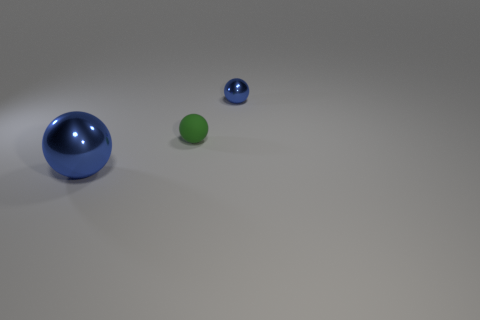What is the shape of the shiny thing that is the same color as the large metal sphere?
Provide a succinct answer. Sphere. There is another thing that is the same size as the rubber thing; what shape is it?
Provide a succinct answer. Sphere. There is a big shiny sphere; are there any small green rubber objects on the right side of it?
Make the answer very short. Yes. Are there any cyan metallic cylinders of the same size as the green sphere?
Give a very brief answer. No. There is a blue shiny sphere that is in front of the small blue ball; how big is it?
Offer a terse response. Large. Is the size of the green thing the same as the blue metal sphere that is right of the tiny green matte thing?
Your response must be concise. Yes. There is a metal sphere that is left of the blue thing that is behind the tiny green ball; what color is it?
Offer a terse response. Blue. Are there an equal number of blue metal spheres that are on the right side of the large blue metal thing and objects that are right of the tiny green matte ball?
Offer a terse response. Yes. Is the material of the blue sphere that is in front of the tiny blue metallic sphere the same as the small blue object?
Keep it short and to the point. Yes. There is a object that is to the left of the small shiny sphere and right of the big metal ball; what color is it?
Make the answer very short. Green. 